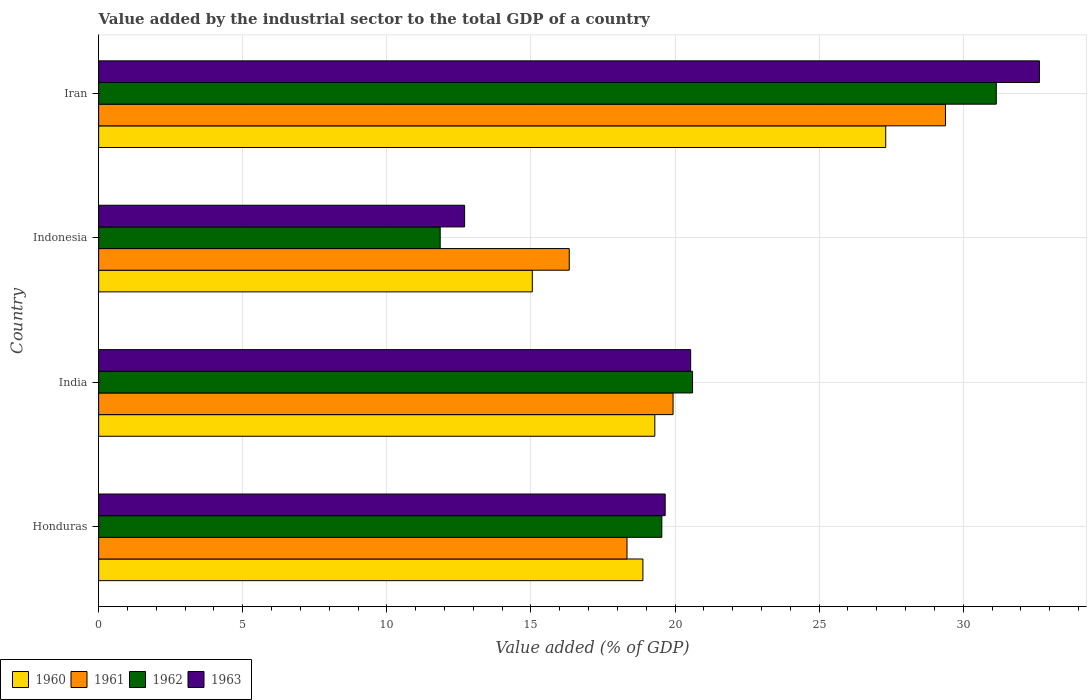How many different coloured bars are there?
Ensure brevity in your answer.  4. Are the number of bars per tick equal to the number of legend labels?
Ensure brevity in your answer.  Yes. How many bars are there on the 2nd tick from the top?
Offer a very short reply. 4. What is the label of the 3rd group of bars from the top?
Provide a succinct answer. India. In how many cases, is the number of bars for a given country not equal to the number of legend labels?
Provide a short and direct response. 0. What is the value added by the industrial sector to the total GDP in 1961 in Indonesia?
Give a very brief answer. 16.33. Across all countries, what is the maximum value added by the industrial sector to the total GDP in 1961?
Your response must be concise. 29.38. Across all countries, what is the minimum value added by the industrial sector to the total GDP in 1961?
Give a very brief answer. 16.33. In which country was the value added by the industrial sector to the total GDP in 1961 maximum?
Your answer should be compact. Iran. What is the total value added by the industrial sector to the total GDP in 1963 in the graph?
Provide a short and direct response. 85.55. What is the difference between the value added by the industrial sector to the total GDP in 1960 in Honduras and that in India?
Your answer should be compact. -0.41. What is the difference between the value added by the industrial sector to the total GDP in 1960 in Honduras and the value added by the industrial sector to the total GDP in 1961 in Iran?
Your answer should be very brief. -10.5. What is the average value added by the industrial sector to the total GDP in 1963 per country?
Provide a short and direct response. 21.39. What is the difference between the value added by the industrial sector to the total GDP in 1962 and value added by the industrial sector to the total GDP in 1963 in Honduras?
Your response must be concise. -0.12. In how many countries, is the value added by the industrial sector to the total GDP in 1961 greater than 28 %?
Make the answer very short. 1. What is the ratio of the value added by the industrial sector to the total GDP in 1960 in Indonesia to that in Iran?
Offer a terse response. 0.55. Is the difference between the value added by the industrial sector to the total GDP in 1962 in India and Iran greater than the difference between the value added by the industrial sector to the total GDP in 1963 in India and Iran?
Offer a very short reply. Yes. What is the difference between the highest and the second highest value added by the industrial sector to the total GDP in 1963?
Keep it short and to the point. 12.1. What is the difference between the highest and the lowest value added by the industrial sector to the total GDP in 1960?
Make the answer very short. 12.26. Is it the case that in every country, the sum of the value added by the industrial sector to the total GDP in 1960 and value added by the industrial sector to the total GDP in 1963 is greater than the sum of value added by the industrial sector to the total GDP in 1961 and value added by the industrial sector to the total GDP in 1962?
Provide a short and direct response. No. What does the 4th bar from the bottom in Indonesia represents?
Your response must be concise. 1963. Is it the case that in every country, the sum of the value added by the industrial sector to the total GDP in 1962 and value added by the industrial sector to the total GDP in 1961 is greater than the value added by the industrial sector to the total GDP in 1963?
Your response must be concise. Yes. How many bars are there?
Keep it short and to the point. 16. Are the values on the major ticks of X-axis written in scientific E-notation?
Your answer should be very brief. No. Does the graph contain any zero values?
Offer a very short reply. No. Does the graph contain grids?
Make the answer very short. Yes. Where does the legend appear in the graph?
Provide a succinct answer. Bottom left. How are the legend labels stacked?
Offer a terse response. Horizontal. What is the title of the graph?
Your answer should be very brief. Value added by the industrial sector to the total GDP of a country. What is the label or title of the X-axis?
Your response must be concise. Value added (% of GDP). What is the label or title of the Y-axis?
Make the answer very short. Country. What is the Value added (% of GDP) of 1960 in Honduras?
Keep it short and to the point. 18.89. What is the Value added (% of GDP) of 1961 in Honduras?
Keep it short and to the point. 18.33. What is the Value added (% of GDP) in 1962 in Honduras?
Provide a short and direct response. 19.54. What is the Value added (% of GDP) of 1963 in Honduras?
Ensure brevity in your answer.  19.66. What is the Value added (% of GDP) in 1960 in India?
Ensure brevity in your answer.  19.3. What is the Value added (% of GDP) in 1961 in India?
Your answer should be very brief. 19.93. What is the Value added (% of GDP) of 1962 in India?
Give a very brief answer. 20.61. What is the Value added (% of GDP) in 1963 in India?
Your answer should be very brief. 20.54. What is the Value added (% of GDP) of 1960 in Indonesia?
Keep it short and to the point. 15.05. What is the Value added (% of GDP) in 1961 in Indonesia?
Provide a short and direct response. 16.33. What is the Value added (% of GDP) in 1962 in Indonesia?
Make the answer very short. 11.85. What is the Value added (% of GDP) of 1963 in Indonesia?
Your answer should be very brief. 12.7. What is the Value added (% of GDP) of 1960 in Iran?
Offer a very short reply. 27.31. What is the Value added (% of GDP) of 1961 in Iran?
Make the answer very short. 29.38. What is the Value added (% of GDP) in 1962 in Iran?
Your response must be concise. 31.15. What is the Value added (% of GDP) of 1963 in Iran?
Provide a short and direct response. 32.65. Across all countries, what is the maximum Value added (% of GDP) in 1960?
Your response must be concise. 27.31. Across all countries, what is the maximum Value added (% of GDP) in 1961?
Provide a short and direct response. 29.38. Across all countries, what is the maximum Value added (% of GDP) in 1962?
Your answer should be compact. 31.15. Across all countries, what is the maximum Value added (% of GDP) in 1963?
Keep it short and to the point. 32.65. Across all countries, what is the minimum Value added (% of GDP) in 1960?
Make the answer very short. 15.05. Across all countries, what is the minimum Value added (% of GDP) in 1961?
Your answer should be compact. 16.33. Across all countries, what is the minimum Value added (% of GDP) in 1962?
Offer a terse response. 11.85. Across all countries, what is the minimum Value added (% of GDP) in 1963?
Provide a short and direct response. 12.7. What is the total Value added (% of GDP) of 1960 in the graph?
Provide a succinct answer. 80.55. What is the total Value added (% of GDP) in 1961 in the graph?
Your response must be concise. 83.98. What is the total Value added (% of GDP) in 1962 in the graph?
Give a very brief answer. 83.15. What is the total Value added (% of GDP) of 1963 in the graph?
Ensure brevity in your answer.  85.55. What is the difference between the Value added (% of GDP) of 1960 in Honduras and that in India?
Give a very brief answer. -0.41. What is the difference between the Value added (% of GDP) of 1961 in Honduras and that in India?
Provide a short and direct response. -1.6. What is the difference between the Value added (% of GDP) in 1962 in Honduras and that in India?
Ensure brevity in your answer.  -1.07. What is the difference between the Value added (% of GDP) in 1963 in Honduras and that in India?
Make the answer very short. -0.88. What is the difference between the Value added (% of GDP) in 1960 in Honduras and that in Indonesia?
Provide a succinct answer. 3.84. What is the difference between the Value added (% of GDP) of 1961 in Honduras and that in Indonesia?
Your response must be concise. 2. What is the difference between the Value added (% of GDP) of 1962 in Honduras and that in Indonesia?
Your response must be concise. 7.69. What is the difference between the Value added (% of GDP) in 1963 in Honduras and that in Indonesia?
Keep it short and to the point. 6.96. What is the difference between the Value added (% of GDP) of 1960 in Honduras and that in Iran?
Keep it short and to the point. -8.43. What is the difference between the Value added (% of GDP) in 1961 in Honduras and that in Iran?
Keep it short and to the point. -11.05. What is the difference between the Value added (% of GDP) of 1962 in Honduras and that in Iran?
Give a very brief answer. -11.61. What is the difference between the Value added (% of GDP) in 1963 in Honduras and that in Iran?
Provide a succinct answer. -12.99. What is the difference between the Value added (% of GDP) in 1960 in India and that in Indonesia?
Your answer should be compact. 4.25. What is the difference between the Value added (% of GDP) in 1961 in India and that in Indonesia?
Your answer should be compact. 3.6. What is the difference between the Value added (% of GDP) of 1962 in India and that in Indonesia?
Offer a very short reply. 8.76. What is the difference between the Value added (% of GDP) in 1963 in India and that in Indonesia?
Offer a very short reply. 7.84. What is the difference between the Value added (% of GDP) of 1960 in India and that in Iran?
Your answer should be very brief. -8.01. What is the difference between the Value added (% of GDP) of 1961 in India and that in Iran?
Provide a succinct answer. -9.45. What is the difference between the Value added (% of GDP) of 1962 in India and that in Iran?
Provide a short and direct response. -10.54. What is the difference between the Value added (% of GDP) of 1963 in India and that in Iran?
Your response must be concise. -12.1. What is the difference between the Value added (% of GDP) in 1960 in Indonesia and that in Iran?
Your response must be concise. -12.26. What is the difference between the Value added (% of GDP) in 1961 in Indonesia and that in Iran?
Offer a terse response. -13.05. What is the difference between the Value added (% of GDP) of 1962 in Indonesia and that in Iran?
Provide a short and direct response. -19.3. What is the difference between the Value added (% of GDP) of 1963 in Indonesia and that in Iran?
Your answer should be compact. -19.95. What is the difference between the Value added (% of GDP) of 1960 in Honduras and the Value added (% of GDP) of 1961 in India?
Your answer should be very brief. -1.05. What is the difference between the Value added (% of GDP) in 1960 in Honduras and the Value added (% of GDP) in 1962 in India?
Keep it short and to the point. -1.72. What is the difference between the Value added (% of GDP) of 1960 in Honduras and the Value added (% of GDP) of 1963 in India?
Your answer should be compact. -1.66. What is the difference between the Value added (% of GDP) of 1961 in Honduras and the Value added (% of GDP) of 1962 in India?
Offer a terse response. -2.27. What is the difference between the Value added (% of GDP) of 1961 in Honduras and the Value added (% of GDP) of 1963 in India?
Give a very brief answer. -2.21. What is the difference between the Value added (% of GDP) of 1962 in Honduras and the Value added (% of GDP) of 1963 in India?
Keep it short and to the point. -1. What is the difference between the Value added (% of GDP) of 1960 in Honduras and the Value added (% of GDP) of 1961 in Indonesia?
Offer a terse response. 2.56. What is the difference between the Value added (% of GDP) of 1960 in Honduras and the Value added (% of GDP) of 1962 in Indonesia?
Provide a succinct answer. 7.03. What is the difference between the Value added (% of GDP) of 1960 in Honduras and the Value added (% of GDP) of 1963 in Indonesia?
Offer a terse response. 6.19. What is the difference between the Value added (% of GDP) of 1961 in Honduras and the Value added (% of GDP) of 1962 in Indonesia?
Ensure brevity in your answer.  6.48. What is the difference between the Value added (% of GDP) in 1961 in Honduras and the Value added (% of GDP) in 1963 in Indonesia?
Provide a short and direct response. 5.64. What is the difference between the Value added (% of GDP) in 1962 in Honduras and the Value added (% of GDP) in 1963 in Indonesia?
Offer a terse response. 6.84. What is the difference between the Value added (% of GDP) of 1960 in Honduras and the Value added (% of GDP) of 1961 in Iran?
Your response must be concise. -10.5. What is the difference between the Value added (% of GDP) of 1960 in Honduras and the Value added (% of GDP) of 1962 in Iran?
Your response must be concise. -12.26. What is the difference between the Value added (% of GDP) in 1960 in Honduras and the Value added (% of GDP) in 1963 in Iran?
Provide a succinct answer. -13.76. What is the difference between the Value added (% of GDP) of 1961 in Honduras and the Value added (% of GDP) of 1962 in Iran?
Keep it short and to the point. -12.81. What is the difference between the Value added (% of GDP) of 1961 in Honduras and the Value added (% of GDP) of 1963 in Iran?
Give a very brief answer. -14.31. What is the difference between the Value added (% of GDP) of 1962 in Honduras and the Value added (% of GDP) of 1963 in Iran?
Provide a short and direct response. -13.1. What is the difference between the Value added (% of GDP) of 1960 in India and the Value added (% of GDP) of 1961 in Indonesia?
Your response must be concise. 2.97. What is the difference between the Value added (% of GDP) in 1960 in India and the Value added (% of GDP) in 1962 in Indonesia?
Your answer should be very brief. 7.45. What is the difference between the Value added (% of GDP) of 1960 in India and the Value added (% of GDP) of 1963 in Indonesia?
Provide a short and direct response. 6.6. What is the difference between the Value added (% of GDP) of 1961 in India and the Value added (% of GDP) of 1962 in Indonesia?
Your response must be concise. 8.08. What is the difference between the Value added (% of GDP) of 1961 in India and the Value added (% of GDP) of 1963 in Indonesia?
Give a very brief answer. 7.23. What is the difference between the Value added (% of GDP) of 1962 in India and the Value added (% of GDP) of 1963 in Indonesia?
Give a very brief answer. 7.91. What is the difference between the Value added (% of GDP) in 1960 in India and the Value added (% of GDP) in 1961 in Iran?
Offer a terse response. -10.09. What is the difference between the Value added (% of GDP) of 1960 in India and the Value added (% of GDP) of 1962 in Iran?
Your response must be concise. -11.85. What is the difference between the Value added (% of GDP) of 1960 in India and the Value added (% of GDP) of 1963 in Iran?
Make the answer very short. -13.35. What is the difference between the Value added (% of GDP) in 1961 in India and the Value added (% of GDP) in 1962 in Iran?
Make the answer very short. -11.22. What is the difference between the Value added (% of GDP) of 1961 in India and the Value added (% of GDP) of 1963 in Iran?
Provide a short and direct response. -12.71. What is the difference between the Value added (% of GDP) in 1962 in India and the Value added (% of GDP) in 1963 in Iran?
Make the answer very short. -12.04. What is the difference between the Value added (% of GDP) of 1960 in Indonesia and the Value added (% of GDP) of 1961 in Iran?
Provide a succinct answer. -14.34. What is the difference between the Value added (% of GDP) in 1960 in Indonesia and the Value added (% of GDP) in 1962 in Iran?
Your answer should be compact. -16.1. What is the difference between the Value added (% of GDP) of 1960 in Indonesia and the Value added (% of GDP) of 1963 in Iran?
Offer a very short reply. -17.6. What is the difference between the Value added (% of GDP) in 1961 in Indonesia and the Value added (% of GDP) in 1962 in Iran?
Provide a succinct answer. -14.82. What is the difference between the Value added (% of GDP) in 1961 in Indonesia and the Value added (% of GDP) in 1963 in Iran?
Your answer should be very brief. -16.32. What is the difference between the Value added (% of GDP) in 1962 in Indonesia and the Value added (% of GDP) in 1963 in Iran?
Offer a terse response. -20.79. What is the average Value added (% of GDP) in 1960 per country?
Give a very brief answer. 20.14. What is the average Value added (% of GDP) in 1961 per country?
Your answer should be very brief. 21. What is the average Value added (% of GDP) of 1962 per country?
Your answer should be very brief. 20.79. What is the average Value added (% of GDP) of 1963 per country?
Make the answer very short. 21.39. What is the difference between the Value added (% of GDP) in 1960 and Value added (% of GDP) in 1961 in Honduras?
Provide a short and direct response. 0.55. What is the difference between the Value added (% of GDP) in 1960 and Value added (% of GDP) in 1962 in Honduras?
Your answer should be very brief. -0.66. What is the difference between the Value added (% of GDP) of 1960 and Value added (% of GDP) of 1963 in Honduras?
Offer a terse response. -0.77. What is the difference between the Value added (% of GDP) in 1961 and Value added (% of GDP) in 1962 in Honduras?
Provide a short and direct response. -1.21. What is the difference between the Value added (% of GDP) of 1961 and Value added (% of GDP) of 1963 in Honduras?
Provide a succinct answer. -1.32. What is the difference between the Value added (% of GDP) in 1962 and Value added (% of GDP) in 1963 in Honduras?
Provide a succinct answer. -0.12. What is the difference between the Value added (% of GDP) of 1960 and Value added (% of GDP) of 1961 in India?
Provide a short and direct response. -0.63. What is the difference between the Value added (% of GDP) of 1960 and Value added (% of GDP) of 1962 in India?
Make the answer very short. -1.31. What is the difference between the Value added (% of GDP) in 1960 and Value added (% of GDP) in 1963 in India?
Your answer should be compact. -1.24. What is the difference between the Value added (% of GDP) in 1961 and Value added (% of GDP) in 1962 in India?
Keep it short and to the point. -0.68. What is the difference between the Value added (% of GDP) in 1961 and Value added (% of GDP) in 1963 in India?
Provide a succinct answer. -0.61. What is the difference between the Value added (% of GDP) in 1962 and Value added (% of GDP) in 1963 in India?
Provide a succinct answer. 0.06. What is the difference between the Value added (% of GDP) in 1960 and Value added (% of GDP) in 1961 in Indonesia?
Make the answer very short. -1.28. What is the difference between the Value added (% of GDP) of 1960 and Value added (% of GDP) of 1962 in Indonesia?
Provide a succinct answer. 3.2. What is the difference between the Value added (% of GDP) of 1960 and Value added (% of GDP) of 1963 in Indonesia?
Ensure brevity in your answer.  2.35. What is the difference between the Value added (% of GDP) in 1961 and Value added (% of GDP) in 1962 in Indonesia?
Ensure brevity in your answer.  4.48. What is the difference between the Value added (% of GDP) in 1961 and Value added (% of GDP) in 1963 in Indonesia?
Provide a succinct answer. 3.63. What is the difference between the Value added (% of GDP) in 1962 and Value added (% of GDP) in 1963 in Indonesia?
Provide a short and direct response. -0.85. What is the difference between the Value added (% of GDP) in 1960 and Value added (% of GDP) in 1961 in Iran?
Give a very brief answer. -2.07. What is the difference between the Value added (% of GDP) in 1960 and Value added (% of GDP) in 1962 in Iran?
Your response must be concise. -3.84. What is the difference between the Value added (% of GDP) of 1960 and Value added (% of GDP) of 1963 in Iran?
Offer a very short reply. -5.33. What is the difference between the Value added (% of GDP) of 1961 and Value added (% of GDP) of 1962 in Iran?
Offer a terse response. -1.76. What is the difference between the Value added (% of GDP) of 1961 and Value added (% of GDP) of 1963 in Iran?
Make the answer very short. -3.26. What is the difference between the Value added (% of GDP) of 1962 and Value added (% of GDP) of 1963 in Iran?
Provide a succinct answer. -1.5. What is the ratio of the Value added (% of GDP) in 1960 in Honduras to that in India?
Your answer should be very brief. 0.98. What is the ratio of the Value added (% of GDP) in 1961 in Honduras to that in India?
Ensure brevity in your answer.  0.92. What is the ratio of the Value added (% of GDP) of 1962 in Honduras to that in India?
Offer a terse response. 0.95. What is the ratio of the Value added (% of GDP) in 1963 in Honduras to that in India?
Your answer should be very brief. 0.96. What is the ratio of the Value added (% of GDP) of 1960 in Honduras to that in Indonesia?
Your answer should be compact. 1.25. What is the ratio of the Value added (% of GDP) of 1961 in Honduras to that in Indonesia?
Your answer should be compact. 1.12. What is the ratio of the Value added (% of GDP) of 1962 in Honduras to that in Indonesia?
Give a very brief answer. 1.65. What is the ratio of the Value added (% of GDP) in 1963 in Honduras to that in Indonesia?
Offer a terse response. 1.55. What is the ratio of the Value added (% of GDP) of 1960 in Honduras to that in Iran?
Offer a terse response. 0.69. What is the ratio of the Value added (% of GDP) in 1961 in Honduras to that in Iran?
Make the answer very short. 0.62. What is the ratio of the Value added (% of GDP) of 1962 in Honduras to that in Iran?
Offer a very short reply. 0.63. What is the ratio of the Value added (% of GDP) in 1963 in Honduras to that in Iran?
Ensure brevity in your answer.  0.6. What is the ratio of the Value added (% of GDP) of 1960 in India to that in Indonesia?
Your answer should be very brief. 1.28. What is the ratio of the Value added (% of GDP) of 1961 in India to that in Indonesia?
Your answer should be compact. 1.22. What is the ratio of the Value added (% of GDP) in 1962 in India to that in Indonesia?
Your answer should be compact. 1.74. What is the ratio of the Value added (% of GDP) in 1963 in India to that in Indonesia?
Offer a terse response. 1.62. What is the ratio of the Value added (% of GDP) of 1960 in India to that in Iran?
Provide a short and direct response. 0.71. What is the ratio of the Value added (% of GDP) in 1961 in India to that in Iran?
Offer a terse response. 0.68. What is the ratio of the Value added (% of GDP) of 1962 in India to that in Iran?
Your answer should be very brief. 0.66. What is the ratio of the Value added (% of GDP) in 1963 in India to that in Iran?
Ensure brevity in your answer.  0.63. What is the ratio of the Value added (% of GDP) in 1960 in Indonesia to that in Iran?
Give a very brief answer. 0.55. What is the ratio of the Value added (% of GDP) of 1961 in Indonesia to that in Iran?
Ensure brevity in your answer.  0.56. What is the ratio of the Value added (% of GDP) in 1962 in Indonesia to that in Iran?
Your response must be concise. 0.38. What is the ratio of the Value added (% of GDP) in 1963 in Indonesia to that in Iran?
Give a very brief answer. 0.39. What is the difference between the highest and the second highest Value added (% of GDP) of 1960?
Provide a succinct answer. 8.01. What is the difference between the highest and the second highest Value added (% of GDP) in 1961?
Keep it short and to the point. 9.45. What is the difference between the highest and the second highest Value added (% of GDP) of 1962?
Your answer should be very brief. 10.54. What is the difference between the highest and the second highest Value added (% of GDP) in 1963?
Provide a succinct answer. 12.1. What is the difference between the highest and the lowest Value added (% of GDP) of 1960?
Your answer should be very brief. 12.26. What is the difference between the highest and the lowest Value added (% of GDP) of 1961?
Ensure brevity in your answer.  13.05. What is the difference between the highest and the lowest Value added (% of GDP) in 1962?
Your answer should be compact. 19.3. What is the difference between the highest and the lowest Value added (% of GDP) of 1963?
Provide a short and direct response. 19.95. 